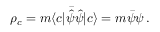<formula> <loc_0><loc_0><loc_500><loc_500>\rho _ { c } = m \langle c | \bar { \hat { \psi } } { \hat { \psi } } | c \rangle = m \bar { \psi } \psi \, .</formula> 